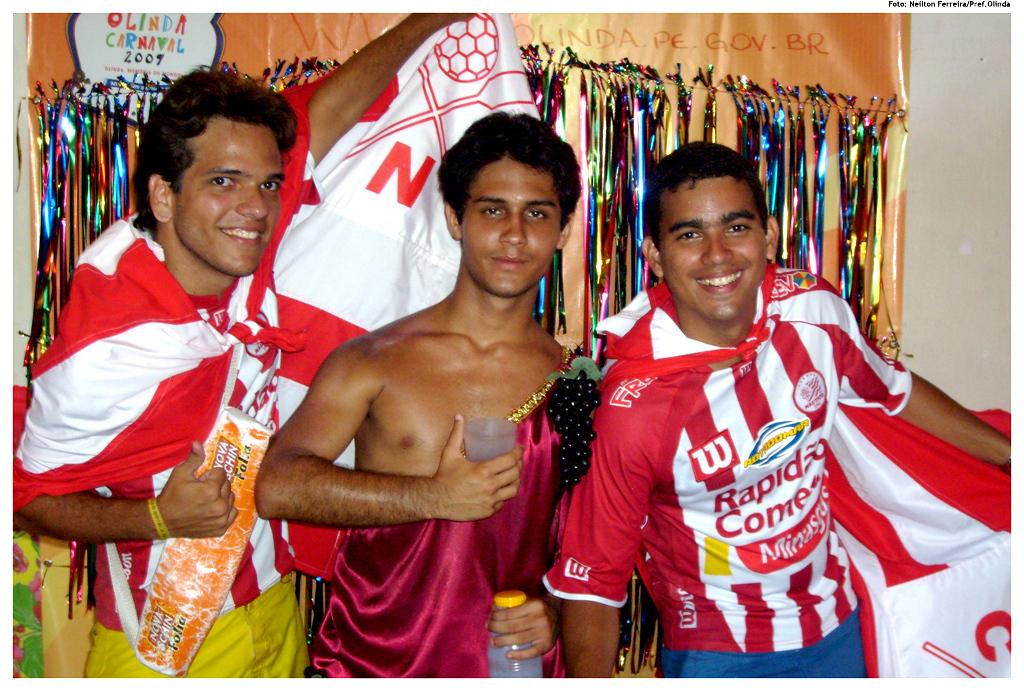<image>
Give a short and clear explanation of the subsequent image. Man smiling for a photo while wearing a jersey which says "Rapid Comes". 